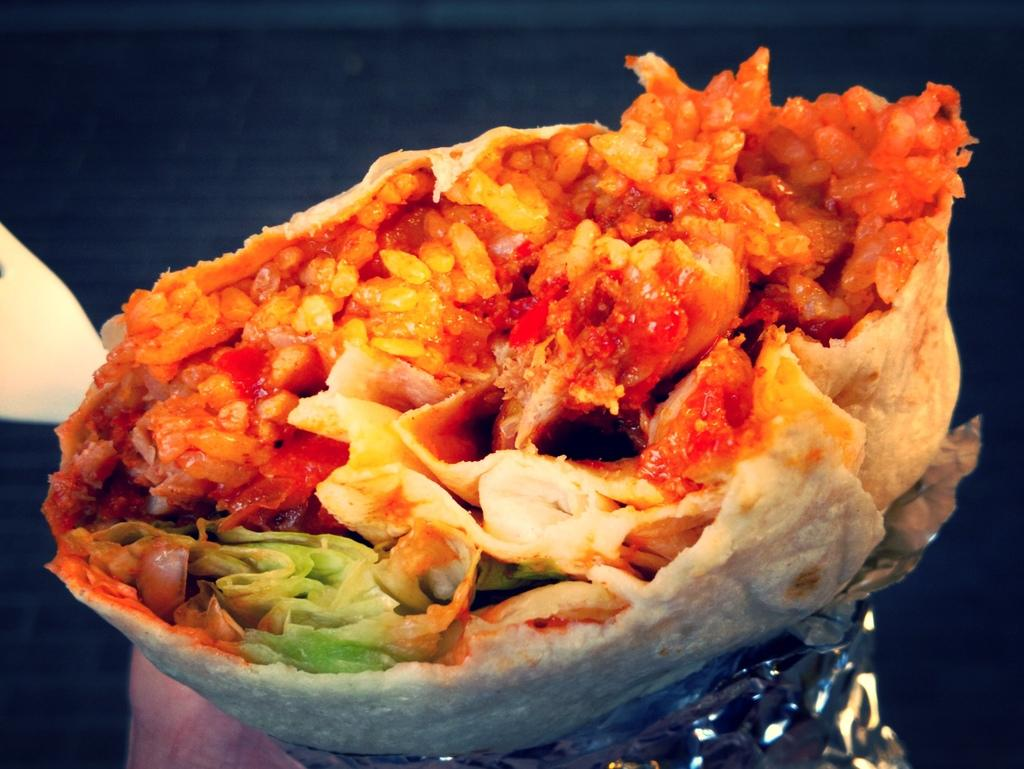What is the main subject in the center of the image? There is food in the center of the image. What material is covering the bottom side of the image? There is an aluminium foil on the bottom side of the image. Can you tell me how many windows are visible in the image? There are no windows visible in the image; it only features food and aluminium foil. What type of humor can be found in the image? There is no humor present in the image; it is a straightforward depiction of food and aluminium foil. 